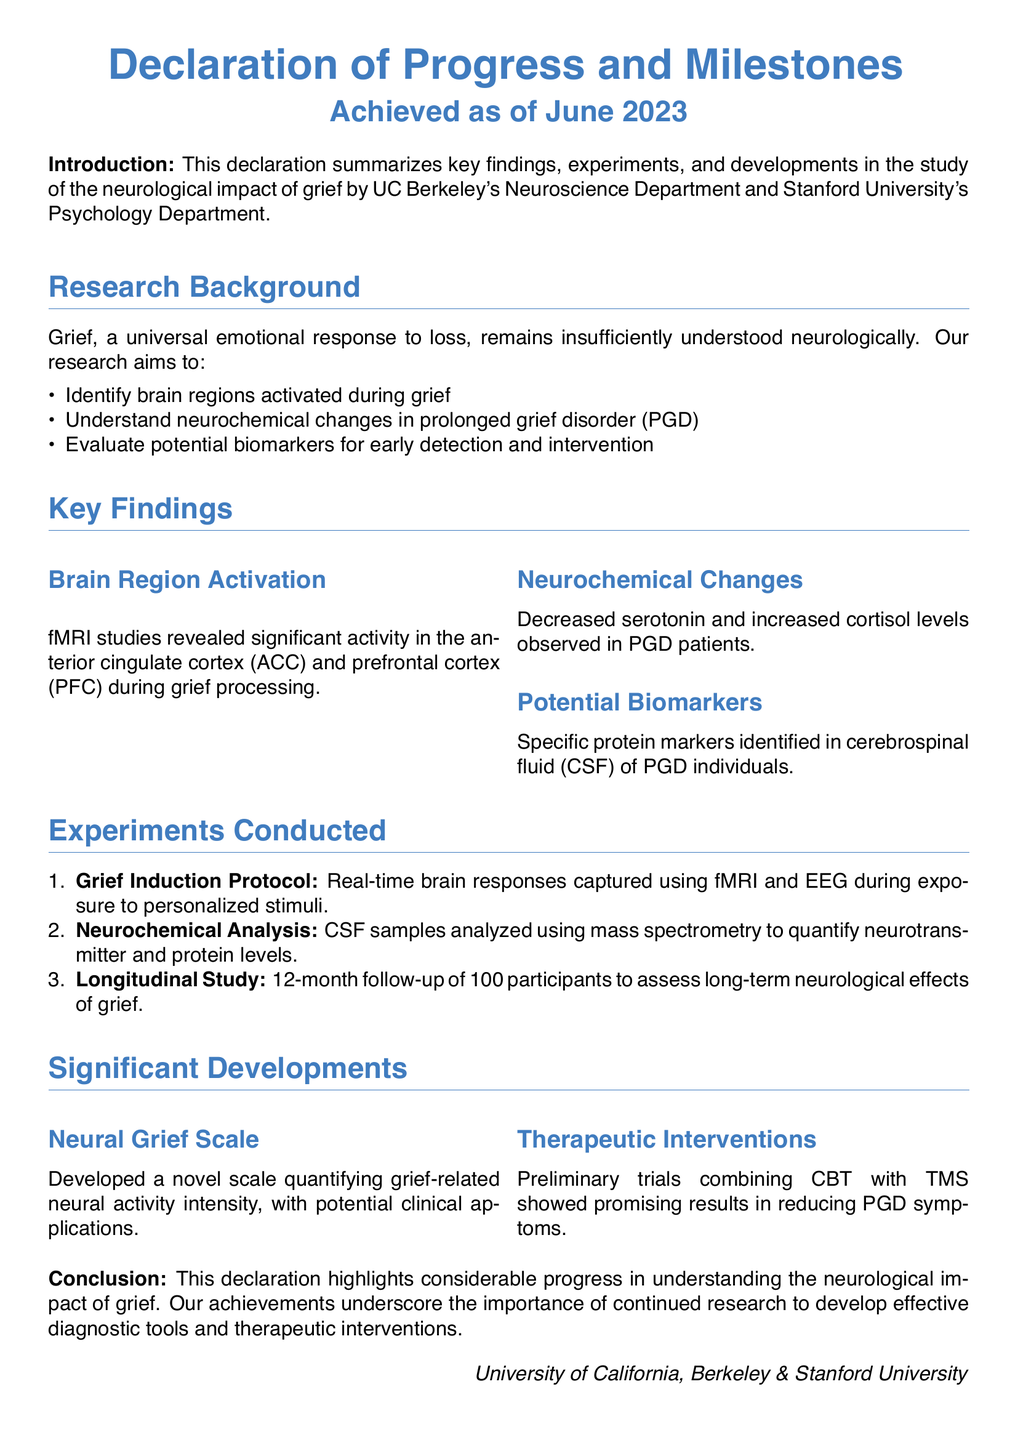What are the institutions involved in the research? The institutions mentioned in the document are the University of California, Berkeley and Stanford University.
Answer: University of California, Berkeley & Stanford University What brain regions are activated during grief processing? The key findings section identifies significant activity in the anterior cingulate cortex and prefrontal cortex during grief processing.
Answer: Anterior cingulate cortex and prefrontal cortex What neurochemical changes were observed in PGD patients? The document states that decreased serotonin and increased cortisol levels were observed in PGD patients.
Answer: Decreased serotonin and increased cortisol How many participants were included in the longitudinal study? The longitudinal study mentioned involves a follow-up of 100 participants to assess long-term neurological effects of grief.
Answer: 100 participants What scale was developed as part of the significant developments? The document refers to the development of a novel scale quantifying grief-related neural activity intensity.
Answer: Neural Grief Scale What therapeutic approach showed promising results in reducing PGD symptoms? The significant developments indicated that combining CBT with TMS showed promising results for PGD symptoms.
Answer: CBT with TMS What is the duration of the follow-up in the longitudinal study? The document specifies that the longitudinal study conducted a 12-month follow-up of participants.
Answer: 12-month follow-up What technique was used to capture real-time brain responses during grief induction? The experiments conducted section mentions that fMRI and EEG were used to capture real-time brain responses.
Answer: fMRI and EEG 